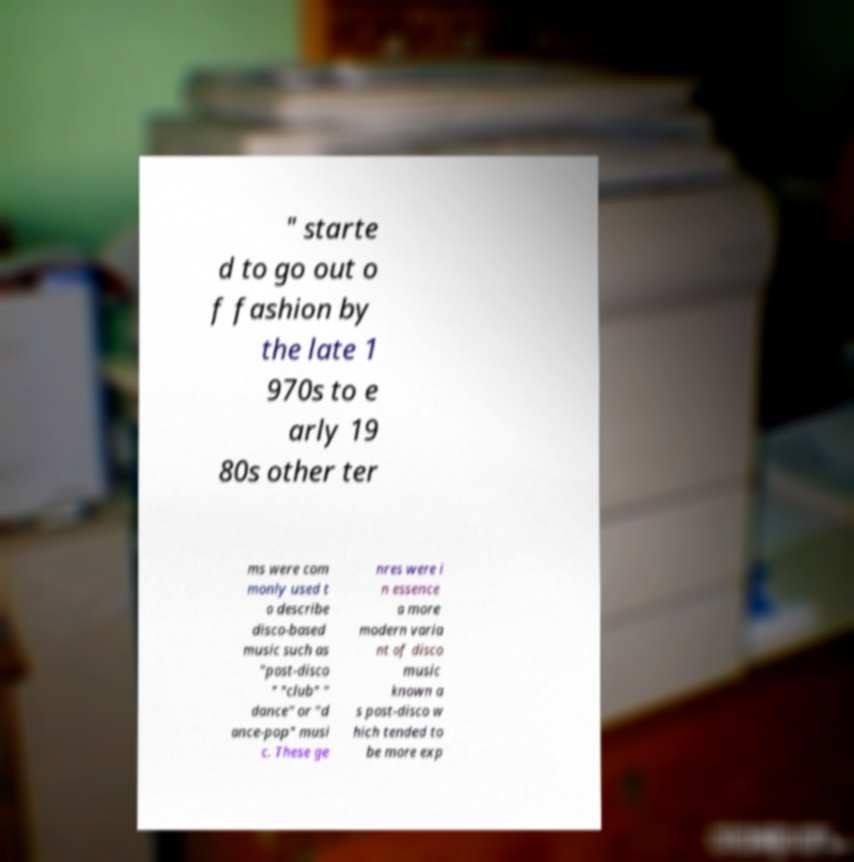Please read and relay the text visible in this image. What does it say? " starte d to go out o f fashion by the late 1 970s to e arly 19 80s other ter ms were com monly used t o describe disco-based music such as "post-disco " "club" " dance" or "d ance-pop" musi c. These ge nres were i n essence a more modern varia nt of disco music known a s post-disco w hich tended to be more exp 